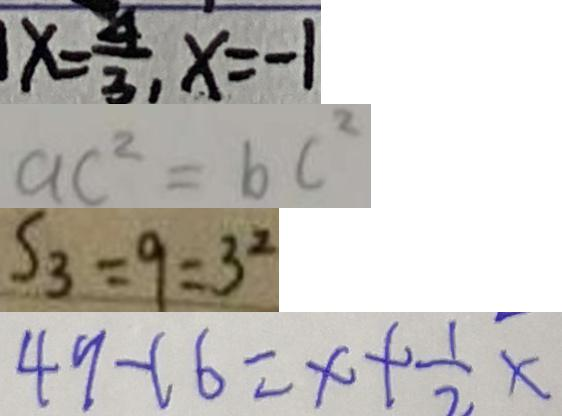Convert formula to latex. <formula><loc_0><loc_0><loc_500><loc_500>x = \frac { 4 } { 3 } , x = - 1 
 a c ^ { 2 } = b c ^ { 2 } 
 S _ { 3 } = 9 = 3 ^ { 2 } 
 4 9 - 1 6 = x + \frac { 1 } { 2 } x</formula> 